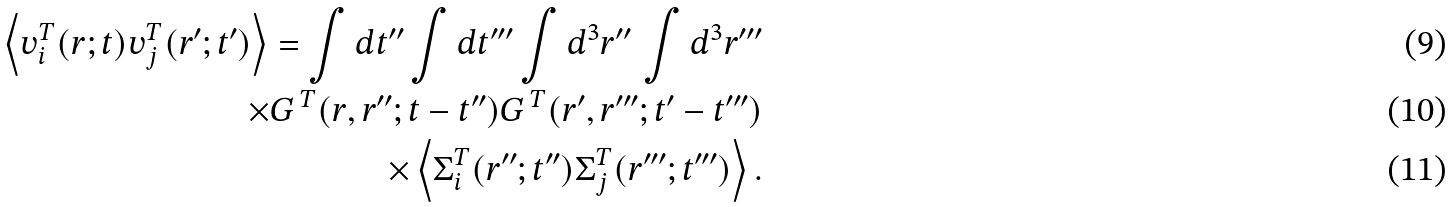Convert formula to latex. <formula><loc_0><loc_0><loc_500><loc_500>\left \langle v _ { i } ^ { T } ( r ; t ) v _ { j } ^ { T } ( r ^ { \prime } ; t ^ { \prime } ) \right \rangle = \int d t ^ { \prime \prime } \int d t ^ { \prime \prime \prime } \int d ^ { 3 } r ^ { \prime \prime } \, \int d ^ { 3 } r ^ { \prime \prime \prime } \\ \times G ^ { \, T } ( r , r ^ { \prime \prime } ; t - t ^ { \prime \prime } ) G ^ { \, T } ( r ^ { \prime } , r ^ { \prime \prime \prime } ; t ^ { \prime } - t ^ { \prime \prime \prime } ) \\ \quad \times \left \langle \Sigma ^ { T } _ { i } ( r ^ { \prime \prime } ; t ^ { \prime \prime } ) \Sigma ^ { T } _ { j } ( r ^ { \prime \prime \prime } ; t ^ { \prime \prime \prime } ) \right \rangle .</formula> 